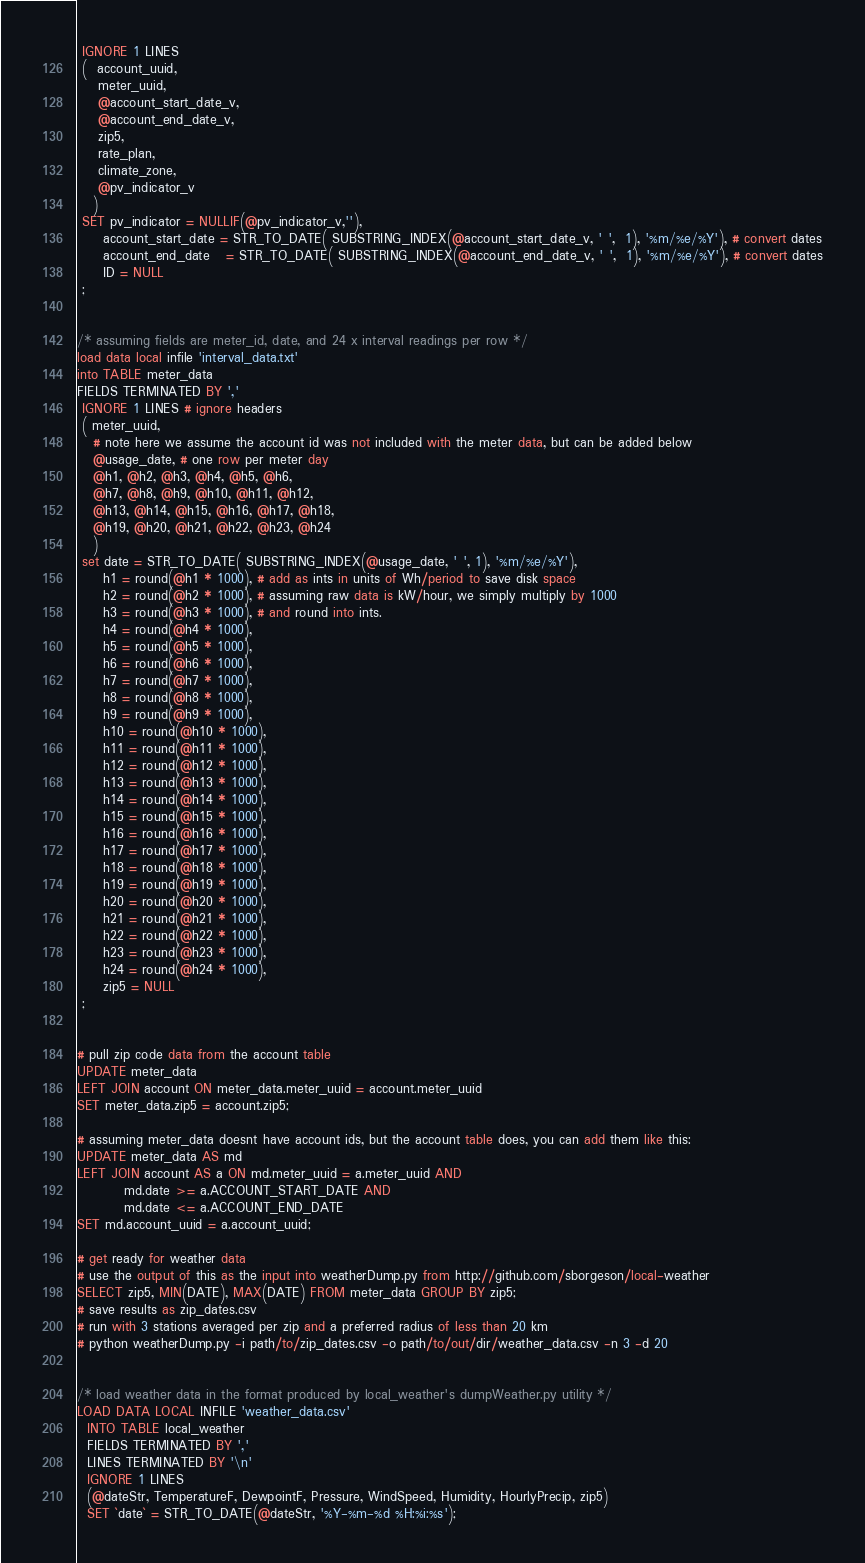<code> <loc_0><loc_0><loc_500><loc_500><_SQL_> IGNORE 1 LINES
 (  account_uuid, 
    meter_uuid,
    @account_start_date_v,
    @account_end_date_v,
    zip5, 
    rate_plan,
    climate_zone, 
    @pv_indicator_v
   )
 SET pv_indicator = NULLIF(@pv_indicator_v,''),
     account_start_date = STR_TO_DATE( SUBSTRING_INDEX(@account_start_date_v, ' ',  1), '%m/%e/%Y'), # convert dates
     account_end_date   = STR_TO_DATE( SUBSTRING_INDEX(@account_end_date_v, ' ',  1), '%m/%e/%Y'), # convert dates
     ID = NULL
 ;


/* assuming fields are meter_id, date, and 24 x interval readings per row */
load data local infile 'interval_data.txt'
into TABLE meter_data
FIELDS TERMINATED BY ','
 IGNORE 1 LINES # ignore headers
 ( meter_uuid, 
   # note here we assume the account id was not included with the meter data, but can be added below
   @usage_date, # one row per meter day
   @h1, @h2, @h3, @h4, @h5, @h6,
   @h7, @h8, @h9, @h10, @h11, @h12,
   @h13, @h14, @h15, @h16, @h17, @h18,
   @h19, @h20, @h21, @h22, @h23, @h24
   )
 set date = STR_TO_DATE( SUBSTRING_INDEX(@usage_date, ' ', 1), '%m/%e/%Y'),
     h1 = round(@h1 * 1000), # add as ints in units of Wh/period to save disk space
     h2 = round(@h2 * 1000), # assuming raw data is kW/hour, we simply multiply by 1000
     h3 = round(@h3 * 1000), # and round into ints.
     h4 = round(@h4 * 1000), 
     h5 = round(@h5 * 1000), 
     h6 = round(@h6 * 1000), 
     h7 = round(@h7 * 1000), 
     h8 = round(@h8 * 1000), 
     h9 = round(@h9 * 1000), 
     h10 = round(@h10 * 1000), 
     h11 = round(@h11 * 1000), 
     h12 = round(@h12 * 1000), 
     h13 = round(@h13 * 1000), 
     h14 = round(@h14 * 1000), 
     h15 = round(@h15 * 1000), 
     h16 = round(@h16 * 1000), 
     h17 = round(@h17 * 1000), 
     h18 = round(@h18 * 1000), 
     h19 = round(@h19 * 1000), 
     h20 = round(@h20 * 1000), 
     h21 = round(@h21 * 1000), 
     h22 = round(@h22 * 1000), 
     h23 = round(@h23 * 1000), 
     h24 = round(@h24 * 1000),
     zip5 = NULL
 ;


# pull zip code data from the account table
UPDATE meter_data 
LEFT JOIN account ON meter_data.meter_uuid = account.meter_uuid
SET meter_data.zip5 = account.zip5;

# assuming meter_data doesnt have account ids, but the account table does, you can add them like this:
UPDATE meter_data AS md
LEFT JOIN account AS a ON md.meter_uuid = a.meter_uuid AND 
         md.date >= a.ACCOUNT_START_DATE AND 
         md.date <= a.ACCOUNT_END_DATE
SET md.account_uuid = a.account_uuid;

# get ready for weather data
# use the output of this as the input into weatherDump.py from http://github.com/sborgeson/local-weather
SELECT zip5, MIN(DATE), MAX(DATE) FROM meter_data GROUP BY zip5;
# save results as zip_dates.csv
# run with 3 stations averaged per zip and a preferred radius of less than 20 km
# python weatherDump.py -i path/to/zip_dates.csv -o path/to/out/dir/weather_data.csv -n 3 -d 20


/* load weather data in the format produced by local_weather's dumpWeather.py utility */
LOAD DATA LOCAL INFILE 'weather_data.csv' 
  INTO TABLE local_weather 
  FIELDS TERMINATED BY ','  
  LINES TERMINATED BY '\n'
  IGNORE 1 LINES
  (@dateStr, TemperatureF, DewpointF, Pressure, WindSpeed, Humidity, HourlyPrecip, zip5)
  SET `date` = STR_TO_DATE(@dateStr, '%Y-%m-%d %H:%i:%s');

</code> 